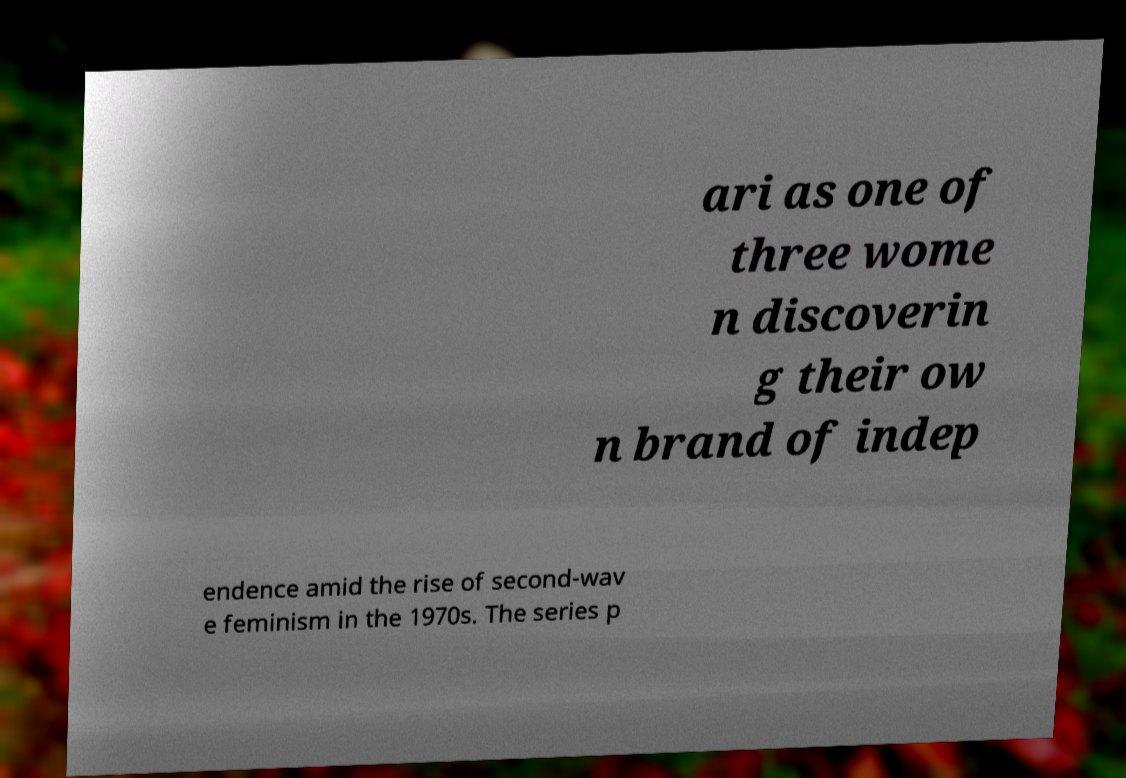I need the written content from this picture converted into text. Can you do that? ari as one of three wome n discoverin g their ow n brand of indep endence amid the rise of second-wav e feminism in the 1970s. The series p 